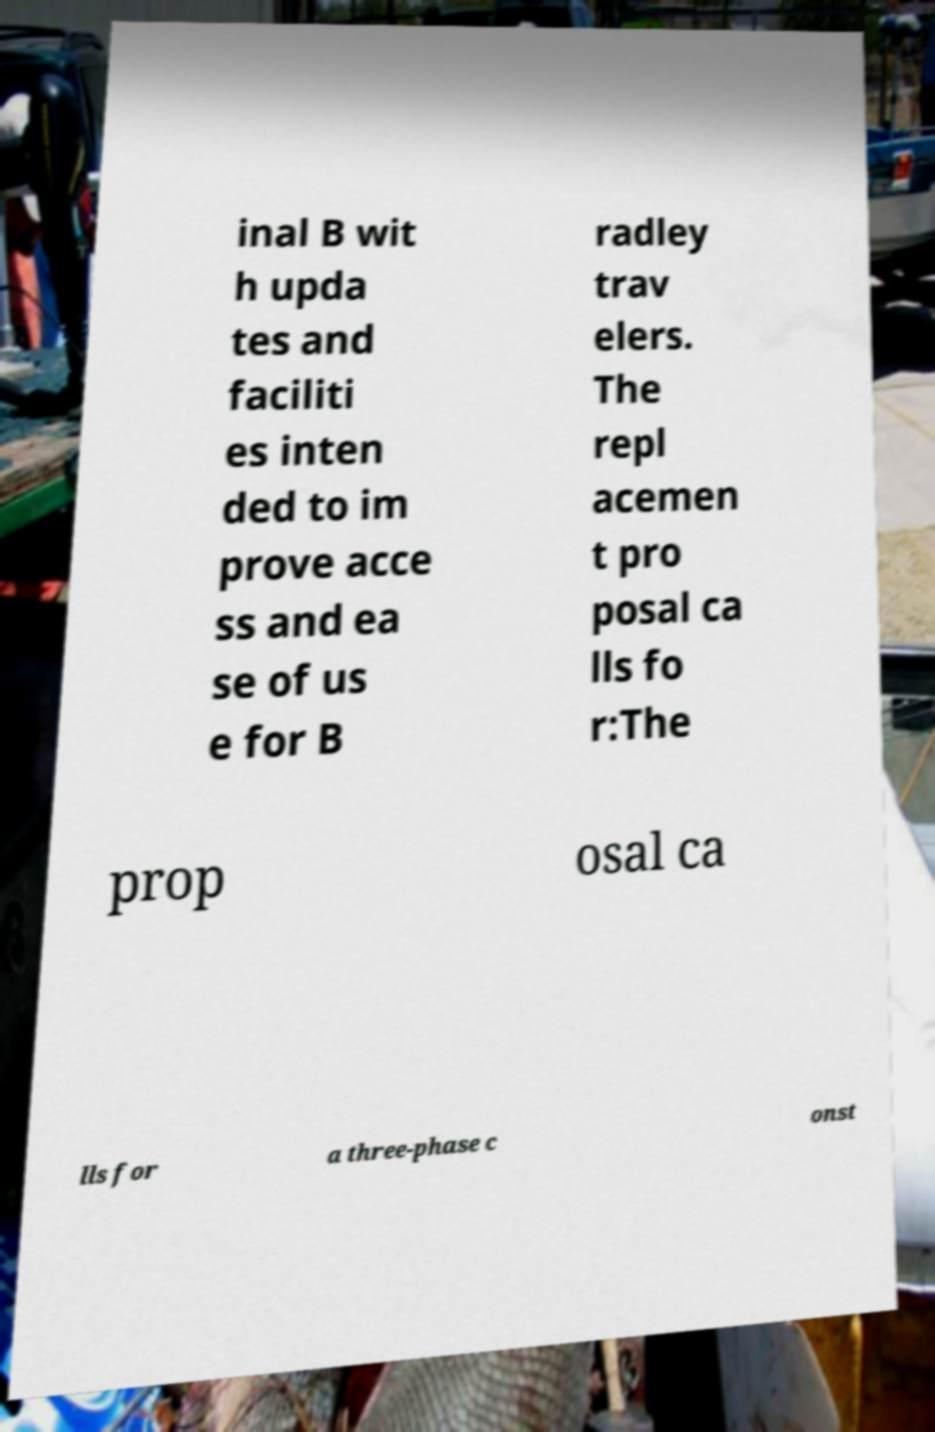What messages or text are displayed in this image? I need them in a readable, typed format. inal B wit h upda tes and faciliti es inten ded to im prove acce ss and ea se of us e for B radley trav elers. The repl acemen t pro posal ca lls fo r:The prop osal ca lls for a three-phase c onst 